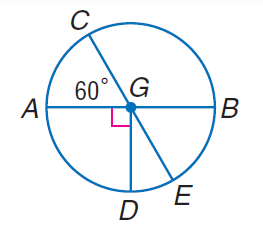Answer the mathemtical geometry problem and directly provide the correct option letter.
Question: Find m \angle A G D.
Choices: A: 45 B: 90 C: 180 D: 360 B 